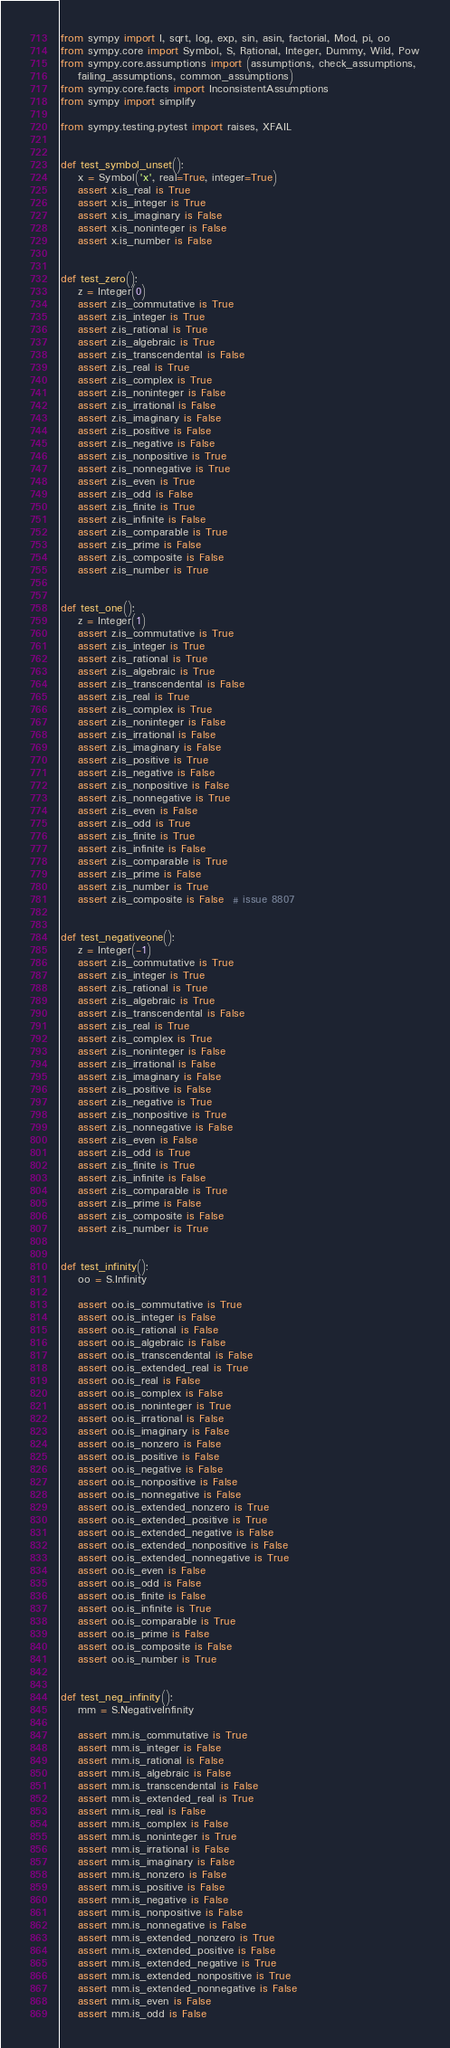<code> <loc_0><loc_0><loc_500><loc_500><_Python_>from sympy import I, sqrt, log, exp, sin, asin, factorial, Mod, pi, oo
from sympy.core import Symbol, S, Rational, Integer, Dummy, Wild, Pow
from sympy.core.assumptions import (assumptions, check_assumptions,
    failing_assumptions, common_assumptions)
from sympy.core.facts import InconsistentAssumptions
from sympy import simplify

from sympy.testing.pytest import raises, XFAIL


def test_symbol_unset():
    x = Symbol('x', real=True, integer=True)
    assert x.is_real is True
    assert x.is_integer is True
    assert x.is_imaginary is False
    assert x.is_noninteger is False
    assert x.is_number is False


def test_zero():
    z = Integer(0)
    assert z.is_commutative is True
    assert z.is_integer is True
    assert z.is_rational is True
    assert z.is_algebraic is True
    assert z.is_transcendental is False
    assert z.is_real is True
    assert z.is_complex is True
    assert z.is_noninteger is False
    assert z.is_irrational is False
    assert z.is_imaginary is False
    assert z.is_positive is False
    assert z.is_negative is False
    assert z.is_nonpositive is True
    assert z.is_nonnegative is True
    assert z.is_even is True
    assert z.is_odd is False
    assert z.is_finite is True
    assert z.is_infinite is False
    assert z.is_comparable is True
    assert z.is_prime is False
    assert z.is_composite is False
    assert z.is_number is True


def test_one():
    z = Integer(1)
    assert z.is_commutative is True
    assert z.is_integer is True
    assert z.is_rational is True
    assert z.is_algebraic is True
    assert z.is_transcendental is False
    assert z.is_real is True
    assert z.is_complex is True
    assert z.is_noninteger is False
    assert z.is_irrational is False
    assert z.is_imaginary is False
    assert z.is_positive is True
    assert z.is_negative is False
    assert z.is_nonpositive is False
    assert z.is_nonnegative is True
    assert z.is_even is False
    assert z.is_odd is True
    assert z.is_finite is True
    assert z.is_infinite is False
    assert z.is_comparable is True
    assert z.is_prime is False
    assert z.is_number is True
    assert z.is_composite is False  # issue 8807


def test_negativeone():
    z = Integer(-1)
    assert z.is_commutative is True
    assert z.is_integer is True
    assert z.is_rational is True
    assert z.is_algebraic is True
    assert z.is_transcendental is False
    assert z.is_real is True
    assert z.is_complex is True
    assert z.is_noninteger is False
    assert z.is_irrational is False
    assert z.is_imaginary is False
    assert z.is_positive is False
    assert z.is_negative is True
    assert z.is_nonpositive is True
    assert z.is_nonnegative is False
    assert z.is_even is False
    assert z.is_odd is True
    assert z.is_finite is True
    assert z.is_infinite is False
    assert z.is_comparable is True
    assert z.is_prime is False
    assert z.is_composite is False
    assert z.is_number is True


def test_infinity():
    oo = S.Infinity

    assert oo.is_commutative is True
    assert oo.is_integer is False
    assert oo.is_rational is False
    assert oo.is_algebraic is False
    assert oo.is_transcendental is False
    assert oo.is_extended_real is True
    assert oo.is_real is False
    assert oo.is_complex is False
    assert oo.is_noninteger is True
    assert oo.is_irrational is False
    assert oo.is_imaginary is False
    assert oo.is_nonzero is False
    assert oo.is_positive is False
    assert oo.is_negative is False
    assert oo.is_nonpositive is False
    assert oo.is_nonnegative is False
    assert oo.is_extended_nonzero is True
    assert oo.is_extended_positive is True
    assert oo.is_extended_negative is False
    assert oo.is_extended_nonpositive is False
    assert oo.is_extended_nonnegative is True
    assert oo.is_even is False
    assert oo.is_odd is False
    assert oo.is_finite is False
    assert oo.is_infinite is True
    assert oo.is_comparable is True
    assert oo.is_prime is False
    assert oo.is_composite is False
    assert oo.is_number is True


def test_neg_infinity():
    mm = S.NegativeInfinity

    assert mm.is_commutative is True
    assert mm.is_integer is False
    assert mm.is_rational is False
    assert mm.is_algebraic is False
    assert mm.is_transcendental is False
    assert mm.is_extended_real is True
    assert mm.is_real is False
    assert mm.is_complex is False
    assert mm.is_noninteger is True
    assert mm.is_irrational is False
    assert mm.is_imaginary is False
    assert mm.is_nonzero is False
    assert mm.is_positive is False
    assert mm.is_negative is False
    assert mm.is_nonpositive is False
    assert mm.is_nonnegative is False
    assert mm.is_extended_nonzero is True
    assert mm.is_extended_positive is False
    assert mm.is_extended_negative is True
    assert mm.is_extended_nonpositive is True
    assert mm.is_extended_nonnegative is False
    assert mm.is_even is False
    assert mm.is_odd is False</code> 